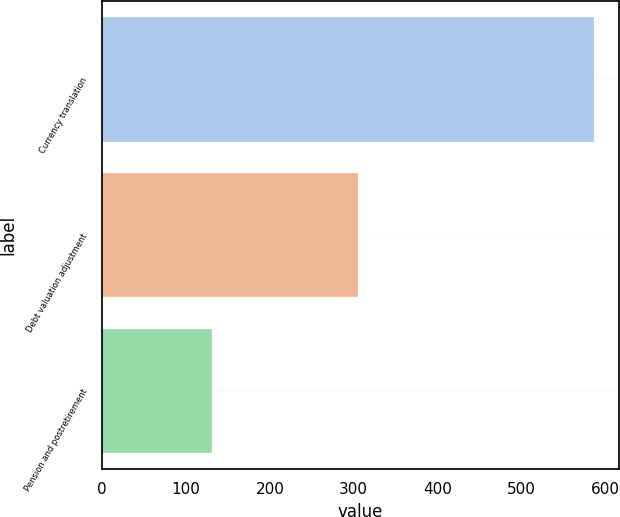<chart> <loc_0><loc_0><loc_500><loc_500><bar_chart><fcel>Currency translation<fcel>Debt valuation adjustment<fcel>Pension and postretirement<nl><fcel>587<fcel>305<fcel>131<nl></chart> 